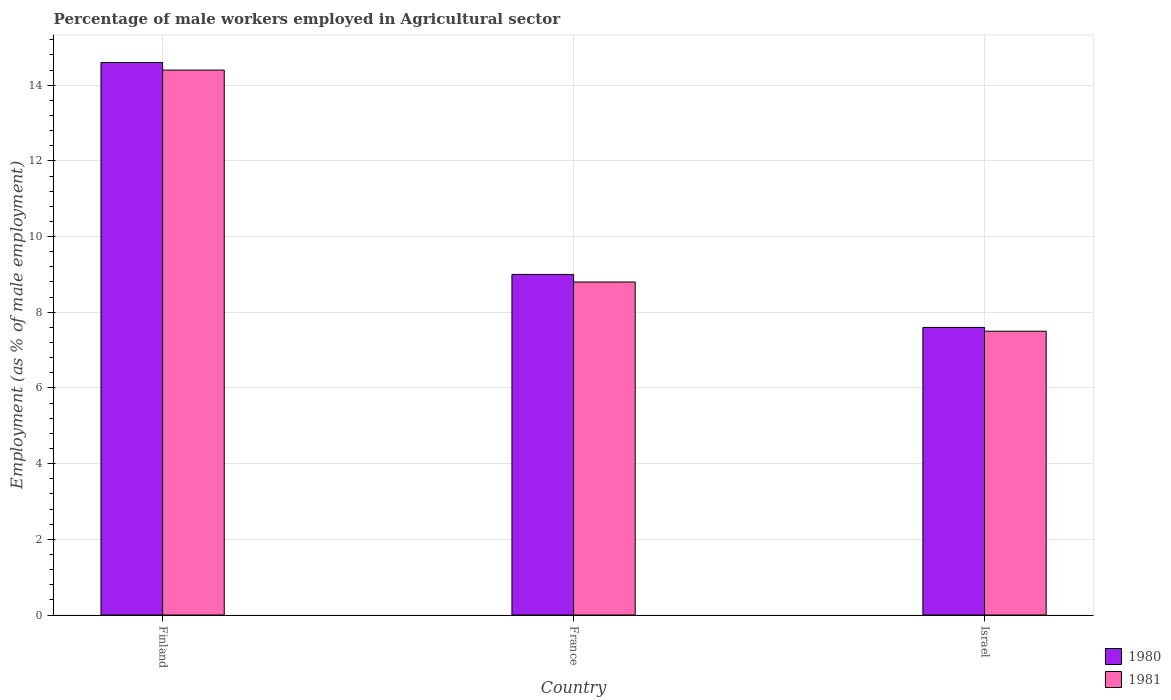How many different coloured bars are there?
Offer a terse response. 2. How many groups of bars are there?
Make the answer very short. 3. Are the number of bars per tick equal to the number of legend labels?
Offer a terse response. Yes. Are the number of bars on each tick of the X-axis equal?
Make the answer very short. Yes. How many bars are there on the 1st tick from the left?
Provide a short and direct response. 2. What is the label of the 3rd group of bars from the left?
Keep it short and to the point. Israel. In how many cases, is the number of bars for a given country not equal to the number of legend labels?
Provide a short and direct response. 0. What is the percentage of male workers employed in Agricultural sector in 1980 in Israel?
Provide a short and direct response. 7.6. Across all countries, what is the maximum percentage of male workers employed in Agricultural sector in 1981?
Offer a terse response. 14.4. Across all countries, what is the minimum percentage of male workers employed in Agricultural sector in 1980?
Make the answer very short. 7.6. In which country was the percentage of male workers employed in Agricultural sector in 1981 minimum?
Provide a succinct answer. Israel. What is the total percentage of male workers employed in Agricultural sector in 1980 in the graph?
Offer a very short reply. 31.2. What is the difference between the percentage of male workers employed in Agricultural sector in 1980 in France and that in Israel?
Ensure brevity in your answer.  1.4. What is the difference between the percentage of male workers employed in Agricultural sector in 1981 in Finland and the percentage of male workers employed in Agricultural sector in 1980 in Israel?
Make the answer very short. 6.8. What is the average percentage of male workers employed in Agricultural sector in 1980 per country?
Your answer should be very brief. 10.4. What is the difference between the percentage of male workers employed in Agricultural sector of/in 1980 and percentage of male workers employed in Agricultural sector of/in 1981 in France?
Provide a short and direct response. 0.2. In how many countries, is the percentage of male workers employed in Agricultural sector in 1980 greater than 3.6 %?
Keep it short and to the point. 3. What is the ratio of the percentage of male workers employed in Agricultural sector in 1981 in France to that in Israel?
Your answer should be compact. 1.17. Is the difference between the percentage of male workers employed in Agricultural sector in 1980 in France and Israel greater than the difference between the percentage of male workers employed in Agricultural sector in 1981 in France and Israel?
Provide a succinct answer. Yes. What is the difference between the highest and the second highest percentage of male workers employed in Agricultural sector in 1980?
Provide a succinct answer. -5.6. What is the difference between the highest and the lowest percentage of male workers employed in Agricultural sector in 1981?
Keep it short and to the point. 6.9. Is the sum of the percentage of male workers employed in Agricultural sector in 1981 in Finland and Israel greater than the maximum percentage of male workers employed in Agricultural sector in 1980 across all countries?
Your answer should be very brief. Yes. What does the 2nd bar from the left in Israel represents?
Offer a terse response. 1981. What does the 1st bar from the right in Finland represents?
Make the answer very short. 1981. How many bars are there?
Provide a short and direct response. 6. Are all the bars in the graph horizontal?
Provide a short and direct response. No. How many countries are there in the graph?
Offer a terse response. 3. What is the difference between two consecutive major ticks on the Y-axis?
Make the answer very short. 2. Are the values on the major ticks of Y-axis written in scientific E-notation?
Ensure brevity in your answer.  No. Does the graph contain grids?
Provide a succinct answer. Yes. How many legend labels are there?
Make the answer very short. 2. What is the title of the graph?
Your answer should be very brief. Percentage of male workers employed in Agricultural sector. What is the label or title of the X-axis?
Give a very brief answer. Country. What is the label or title of the Y-axis?
Ensure brevity in your answer.  Employment (as % of male employment). What is the Employment (as % of male employment) in 1980 in Finland?
Provide a short and direct response. 14.6. What is the Employment (as % of male employment) in 1981 in Finland?
Keep it short and to the point. 14.4. What is the Employment (as % of male employment) in 1981 in France?
Offer a terse response. 8.8. What is the Employment (as % of male employment) of 1980 in Israel?
Offer a terse response. 7.6. Across all countries, what is the maximum Employment (as % of male employment) in 1980?
Your response must be concise. 14.6. Across all countries, what is the maximum Employment (as % of male employment) in 1981?
Give a very brief answer. 14.4. Across all countries, what is the minimum Employment (as % of male employment) of 1980?
Provide a succinct answer. 7.6. Across all countries, what is the minimum Employment (as % of male employment) of 1981?
Offer a very short reply. 7.5. What is the total Employment (as % of male employment) of 1980 in the graph?
Your answer should be compact. 31.2. What is the total Employment (as % of male employment) of 1981 in the graph?
Provide a short and direct response. 30.7. What is the difference between the Employment (as % of male employment) in 1980 in Finland and that in France?
Provide a succinct answer. 5.6. What is the difference between the Employment (as % of male employment) in 1980 in France and that in Israel?
Ensure brevity in your answer.  1.4. What is the difference between the Employment (as % of male employment) of 1980 in Finland and the Employment (as % of male employment) of 1981 in France?
Keep it short and to the point. 5.8. What is the difference between the Employment (as % of male employment) of 1980 in France and the Employment (as % of male employment) of 1981 in Israel?
Provide a short and direct response. 1.5. What is the average Employment (as % of male employment) in 1981 per country?
Provide a succinct answer. 10.23. What is the difference between the Employment (as % of male employment) of 1980 and Employment (as % of male employment) of 1981 in Finland?
Offer a terse response. 0.2. What is the difference between the Employment (as % of male employment) of 1980 and Employment (as % of male employment) of 1981 in France?
Make the answer very short. 0.2. What is the ratio of the Employment (as % of male employment) in 1980 in Finland to that in France?
Keep it short and to the point. 1.62. What is the ratio of the Employment (as % of male employment) of 1981 in Finland to that in France?
Offer a terse response. 1.64. What is the ratio of the Employment (as % of male employment) in 1980 in Finland to that in Israel?
Make the answer very short. 1.92. What is the ratio of the Employment (as % of male employment) in 1981 in Finland to that in Israel?
Provide a succinct answer. 1.92. What is the ratio of the Employment (as % of male employment) of 1980 in France to that in Israel?
Offer a terse response. 1.18. What is the ratio of the Employment (as % of male employment) of 1981 in France to that in Israel?
Offer a terse response. 1.17. What is the difference between the highest and the second highest Employment (as % of male employment) in 1980?
Make the answer very short. 5.6. What is the difference between the highest and the second highest Employment (as % of male employment) in 1981?
Your answer should be very brief. 5.6. What is the difference between the highest and the lowest Employment (as % of male employment) in 1980?
Your response must be concise. 7. What is the difference between the highest and the lowest Employment (as % of male employment) in 1981?
Give a very brief answer. 6.9. 